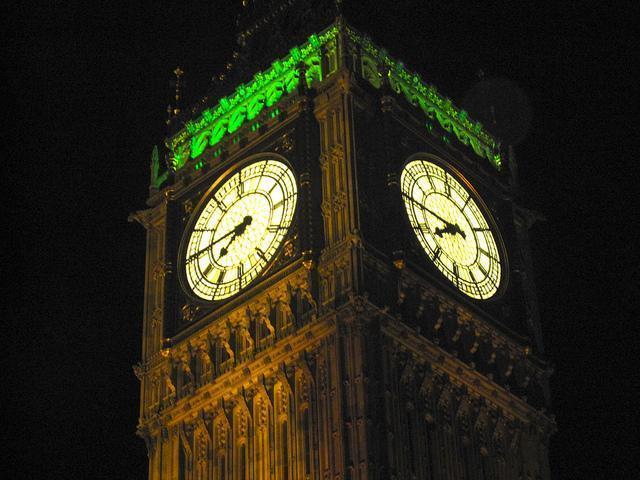How many clocks on the building?
Give a very brief answer. 2. How many clocks are there?
Give a very brief answer. 2. 